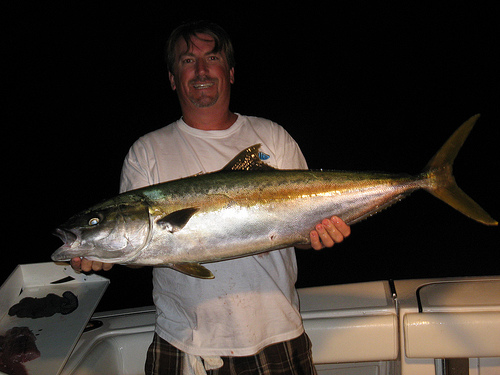<image>
Is there a fish in the shirt? No. The fish is not contained within the shirt. These objects have a different spatial relationship. 